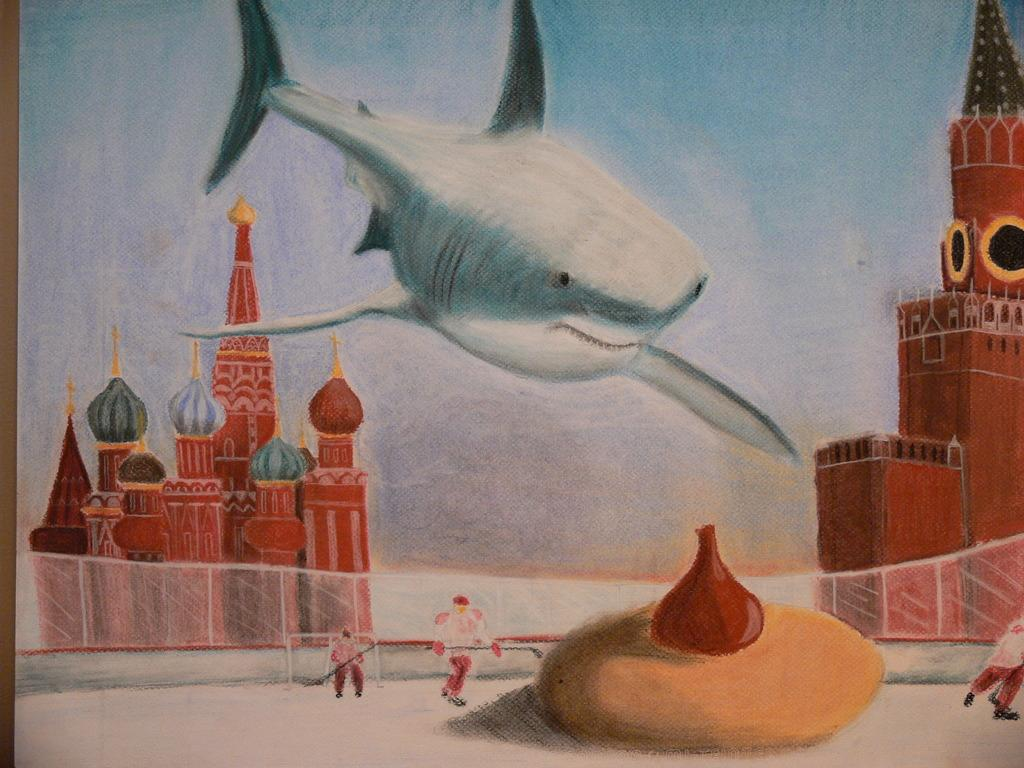What is depicted in the painting in the image? There is a painting of a fish in the image. What type of structures can be seen in the image? There are two buildings in the image. How many people are visible in the image? There are few persons in the image. What is the object on the rock at the bottom of the image? The object on the rock is not specified in the facts provided. What is visible in the background of the image? The sky is visible in the background of the image. What is the rhythm of the coil in the image? There is no coil present in the image, so it is not possible to determine its rhythm. 